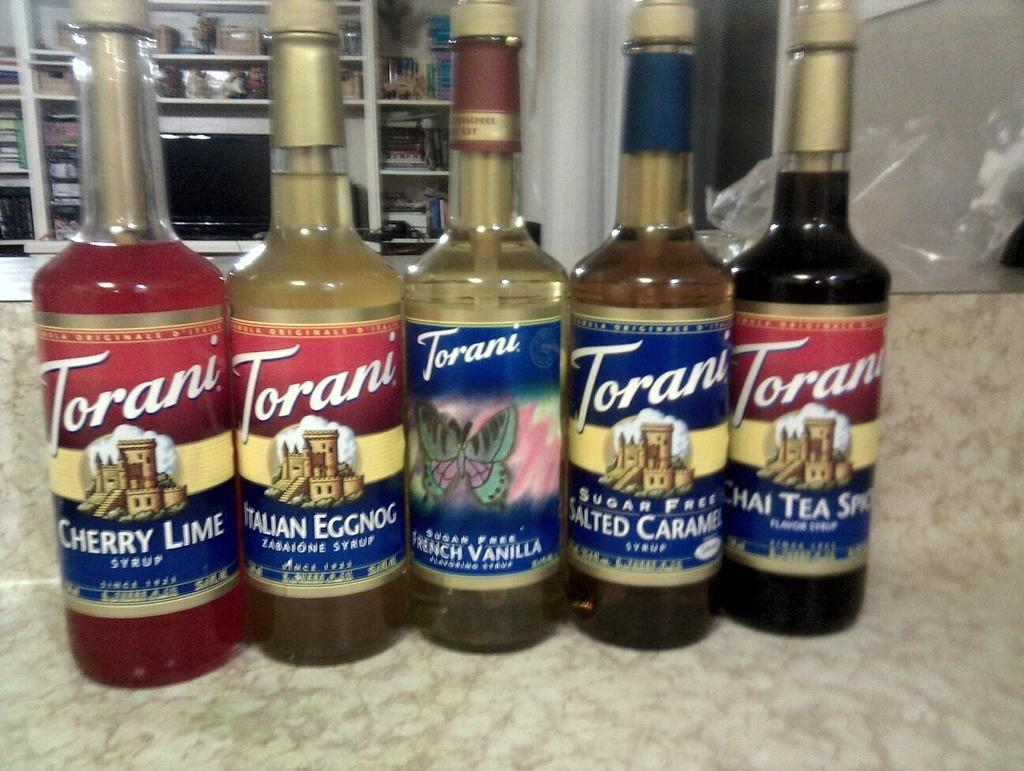What is on the table in the image? There is a group of bottles on a table in the image. What is inside the bottles? The bottles contain liquid. What electronic device is present in the image? There is a television in the image. What type of storage or display can be seen in the image? There are objects on shelves in the image. What type of grass can be seen growing on the television in the image? There is no grass present on the television in the image. 